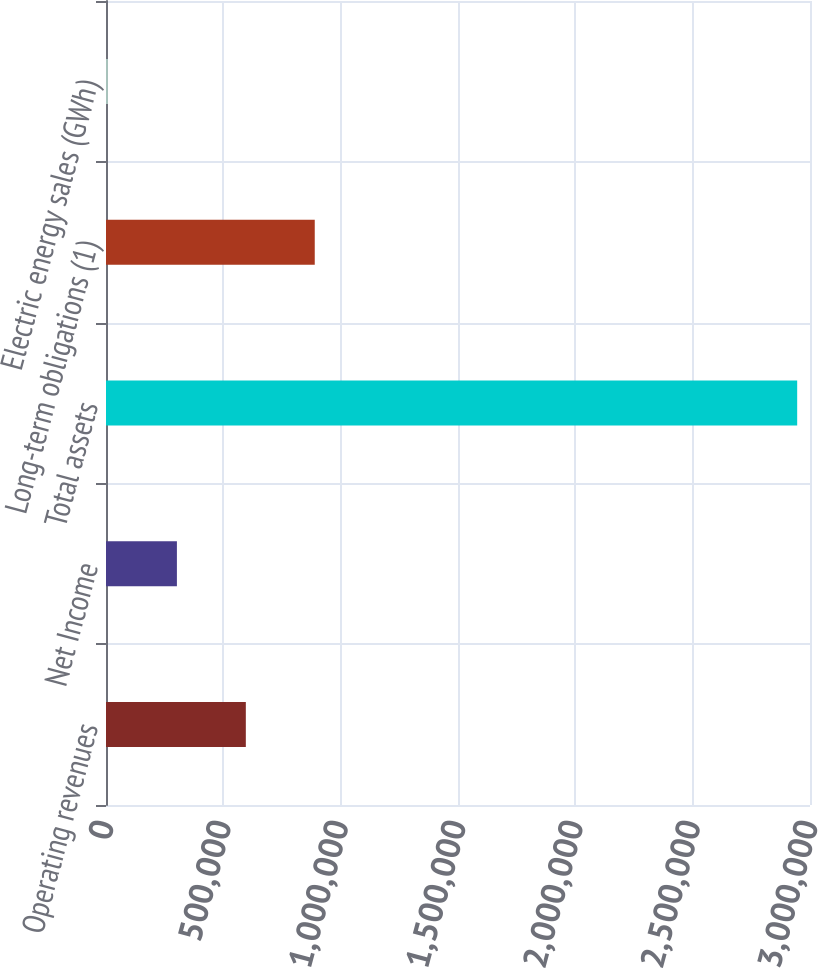Convert chart. <chart><loc_0><loc_0><loc_500><loc_500><bar_chart><fcel>Operating revenues<fcel>Net Income<fcel>Total assets<fcel>Long-term obligations (1)<fcel>Electric energy sales (GWh)<nl><fcel>595858<fcel>302166<fcel>2.94539e+06<fcel>889550<fcel>8475<nl></chart> 